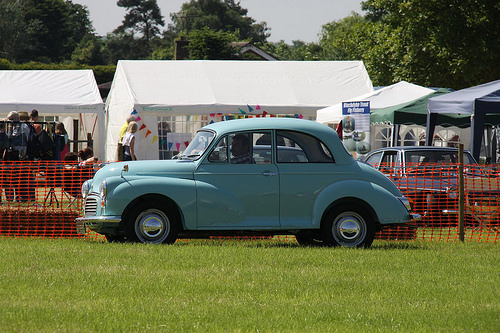<image>
Is the car under the person? No. The car is not positioned under the person. The vertical relationship between these objects is different. Is there a car next to the car? No. The car is not positioned next to the car. They are located in different areas of the scene. 